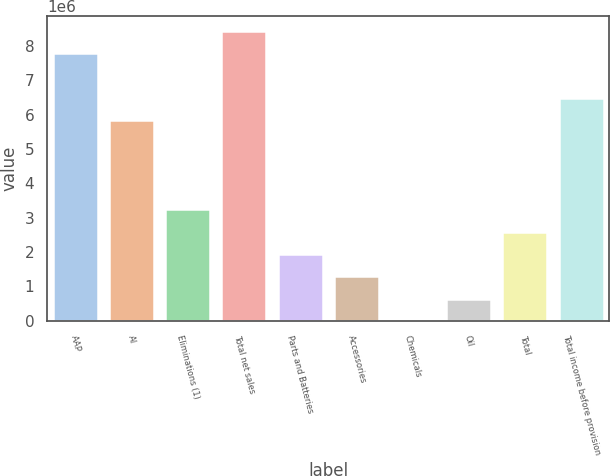<chart> <loc_0><loc_0><loc_500><loc_500><bar_chart><fcel>AAP<fcel>AI<fcel>Eliminations (1)<fcel>Total net sales<fcel>Parts and Batteries<fcel>Accessories<fcel>Chemicals<fcel>Oil<fcel>Total<fcel>Total income before provision<nl><fcel>7.79257e+06<fcel>5.84443e+06<fcel>3.24691e+06<fcel>8.44196e+06<fcel>1.94815e+06<fcel>1.29877e+06<fcel>10<fcel>649390<fcel>2.59753e+06<fcel>6.49381e+06<nl></chart> 